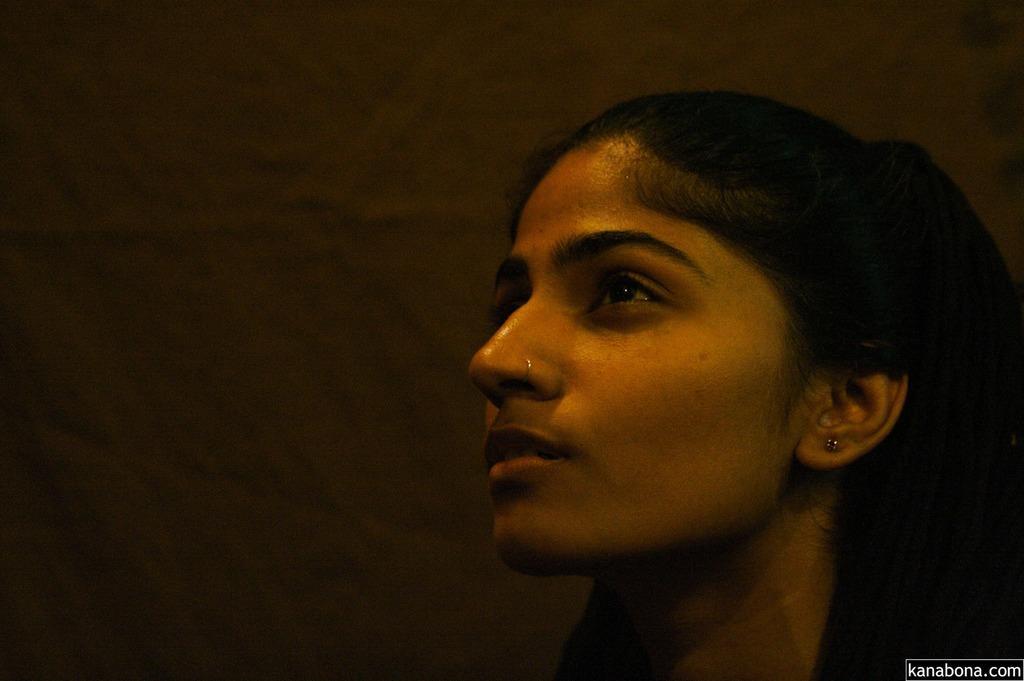Can you describe this image briefly? In this image in the front there is a woman. 